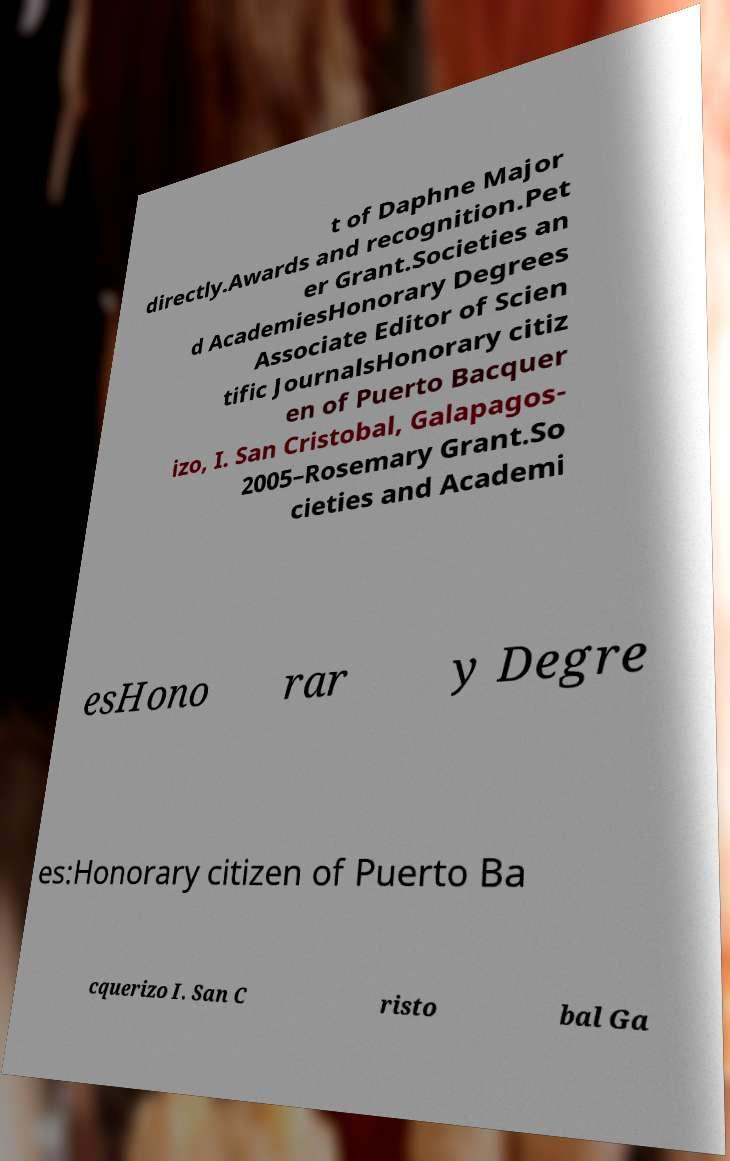What messages or text are displayed in this image? I need them in a readable, typed format. t of Daphne Major directly.Awards and recognition.Pet er Grant.Societies an d AcademiesHonorary Degrees Associate Editor of Scien tific JournalsHonorary citiz en of Puerto Bacquer izo, I. San Cristobal, Galapagos- 2005–Rosemary Grant.So cieties and Academi esHono rar y Degre es:Honorary citizen of Puerto Ba cquerizo I. San C risto bal Ga 